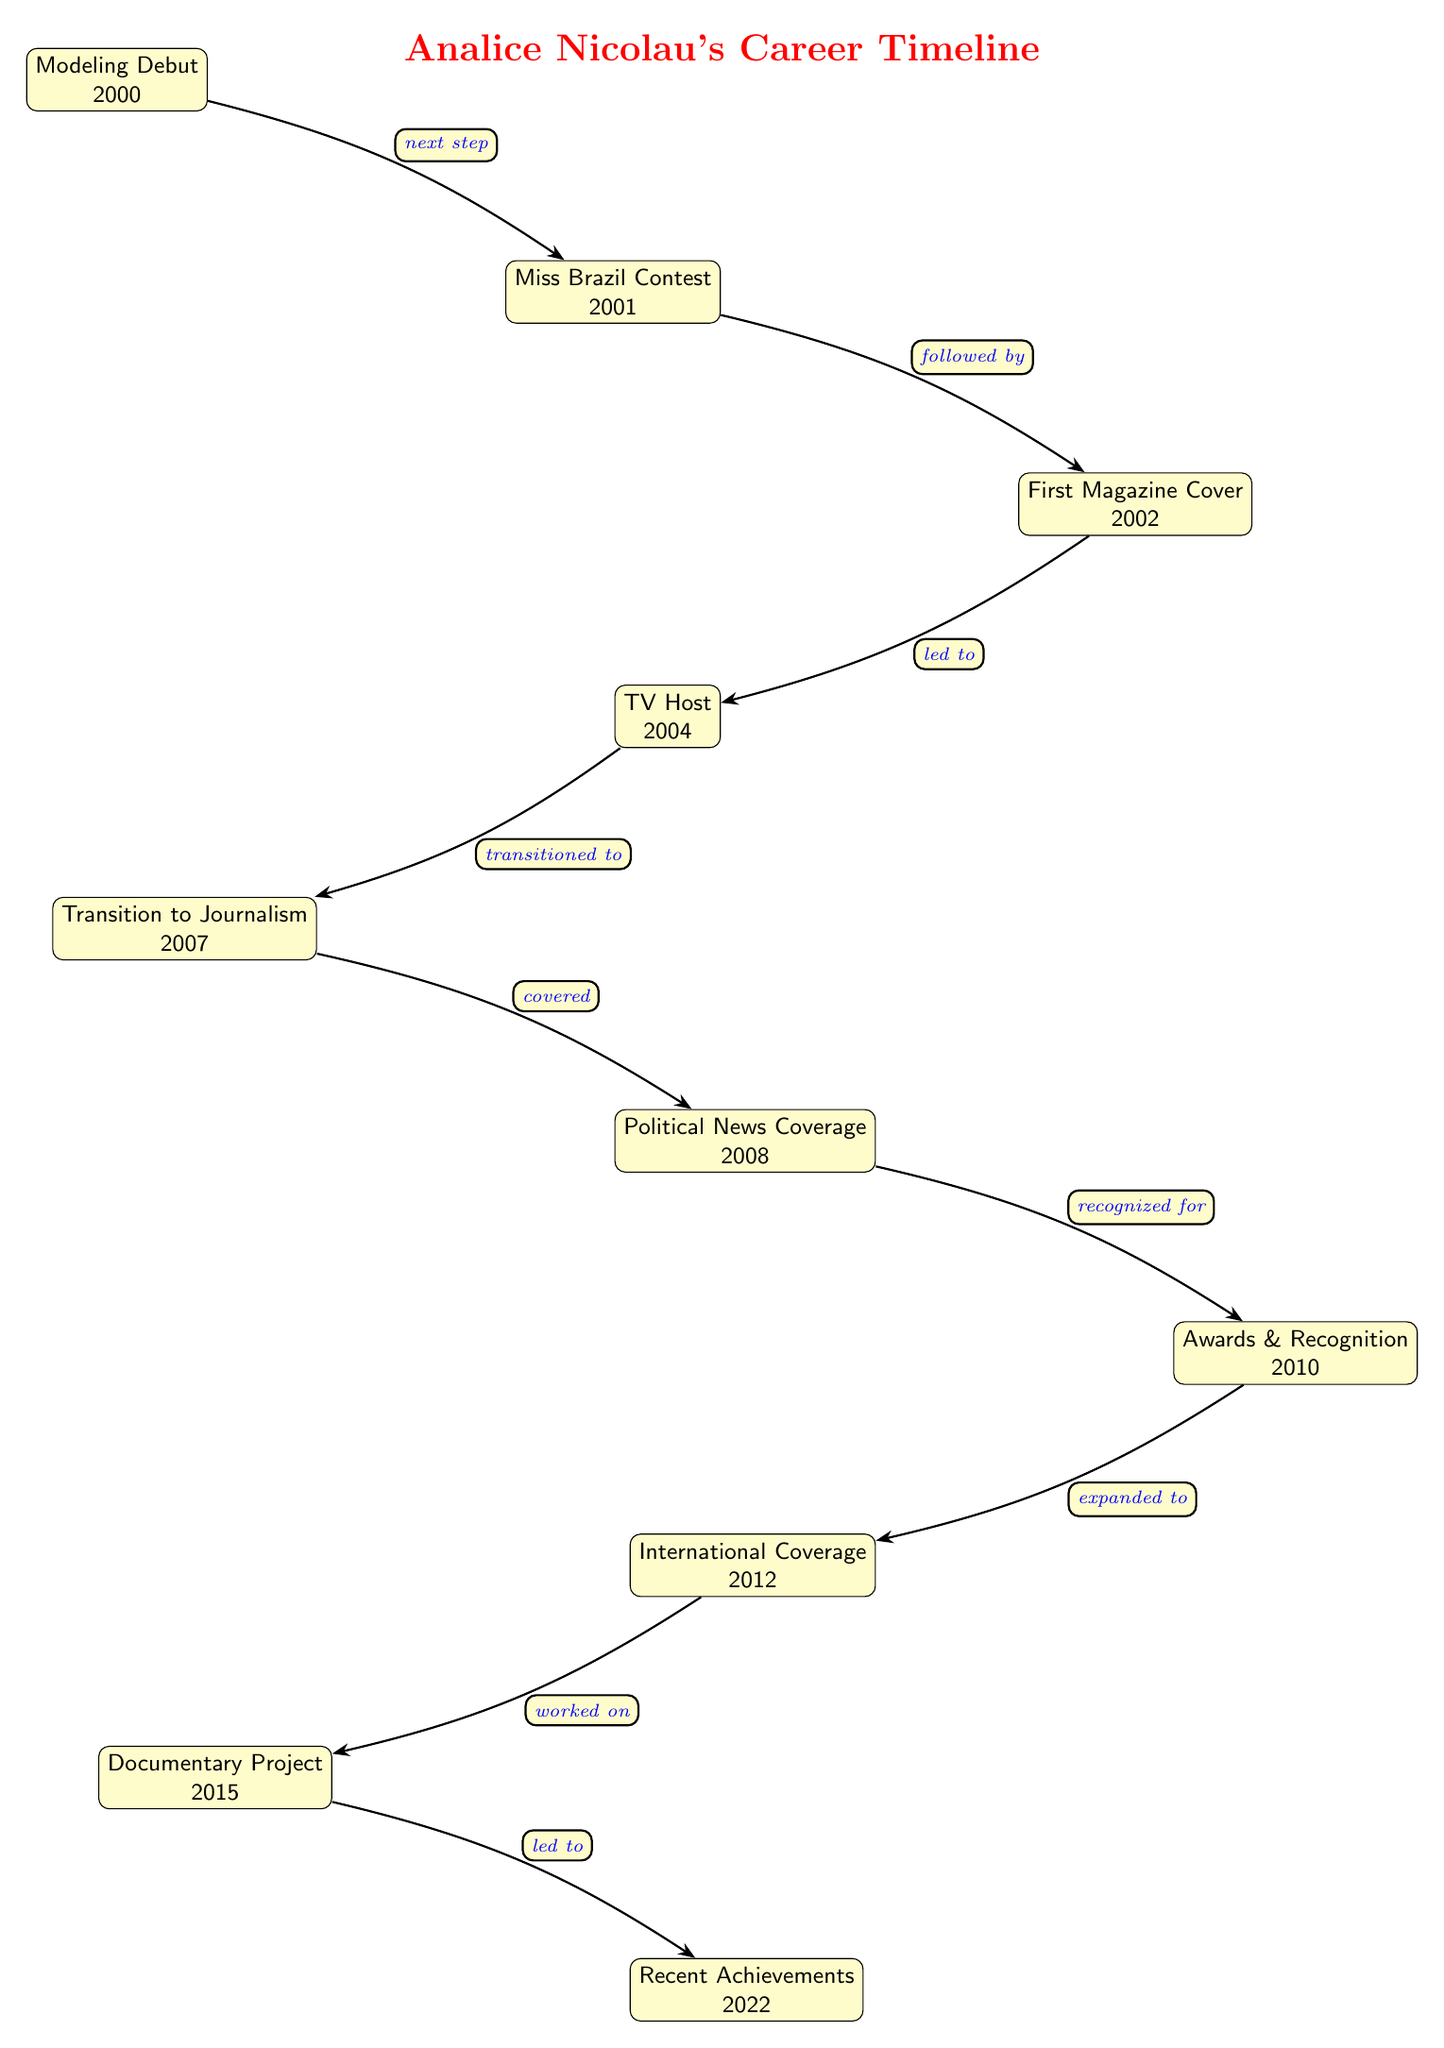What year did Analice Nicolau make her modeling debut? The diagram states that Analice Nicolau's modeling debut occurred in 2000, as represented by the first node in the timeline.
Answer: 2000 What event directly followed the Miss Brazil Contest? According to the diagram, the Miss Brazil Contest in 2001 was directly followed by her first magazine cover in 2002, indicated by the arrow connecting the two nodes.
Answer: First Magazine Cover How many key milestones are included in the career timeline? By counting the nodes in the diagram, there are a total of 10 key milestones related to Analice Nicolau’s career, each representing an important event.
Answer: 10 What milestone is associated with the year 2012? The diagram shows that the milestone corresponding to the year 2012 is "International Coverage," which is indicated by the node at that position in the timeline.
Answer: International Coverage What was the transition from TV Host to Journalism characterized as? The diagram describes the transition from TV Host to Journalism as a "transitioned to," reflecting the movement from one career phase to another via the connecting edge in the diagram.
Answer: transitioned to What achievement did Analice Nicolau receive recognition for in 2010? The node related to the year 2010 is labeled "Awards & Recognition," indicating that this milestone refers to her receiving various awards for her work during that time.
Answer: Awards & Recognition What project did she work on in 2015? The diagram identifies the project she worked on in 2015 as the "Documentary Project," marked clearly in the timeline.
Answer: Documentary Project How is the political news coverage phase related to her journalism transition? The diagram reveals that the political news coverage phase in 2008 is described as being "covered," which indicates that it is a direct result of her transition to journalism in 2007.
Answer: covered What was a significant development in Analice Nicolau's career after 2015? Following the 2015 Documentary Project, the next significant development in her career, as noted in the timeline, is her "Recent Achievements" in 2022.
Answer: Recent Achievements 